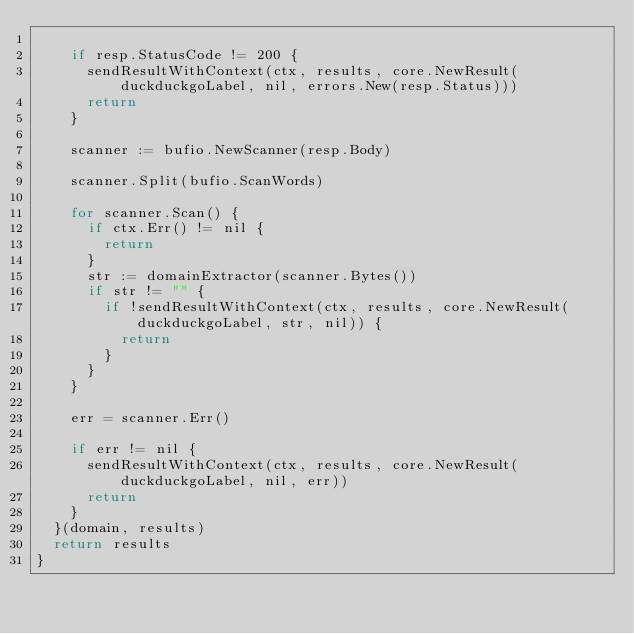<code> <loc_0><loc_0><loc_500><loc_500><_Go_>
		if resp.StatusCode != 200 {
			sendResultWithContext(ctx, results, core.NewResult(duckduckgoLabel, nil, errors.New(resp.Status)))
			return
		}

		scanner := bufio.NewScanner(resp.Body)

		scanner.Split(bufio.ScanWords)

		for scanner.Scan() {
			if ctx.Err() != nil {
				return
			}
			str := domainExtractor(scanner.Bytes())
			if str != "" {
				if !sendResultWithContext(ctx, results, core.NewResult(duckduckgoLabel, str, nil)) {
					return
				}
			}
		}

		err = scanner.Err()

		if err != nil {
			sendResultWithContext(ctx, results, core.NewResult(duckduckgoLabel, nil, err))
			return
		}
	}(domain, results)
	return results
}
</code> 